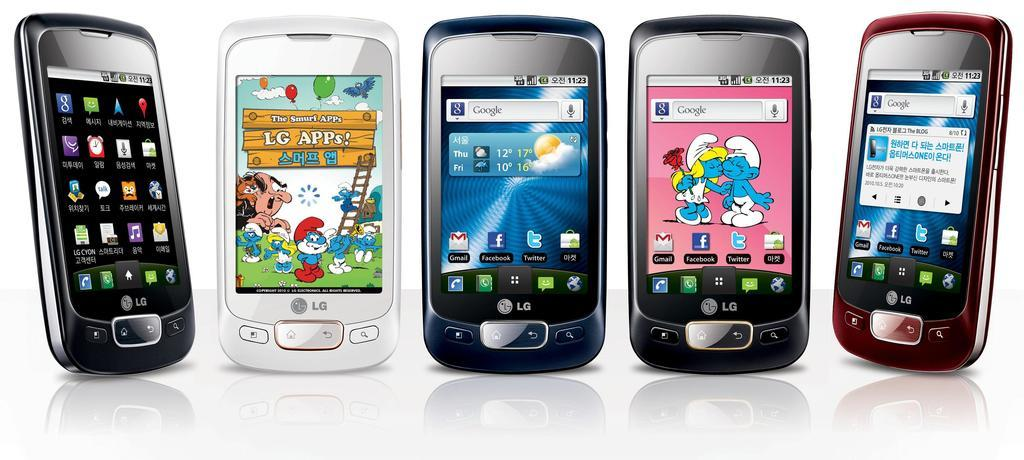Provide a one-sentence caption for the provided image. Multiple mobile devices near each other at 11:23. 